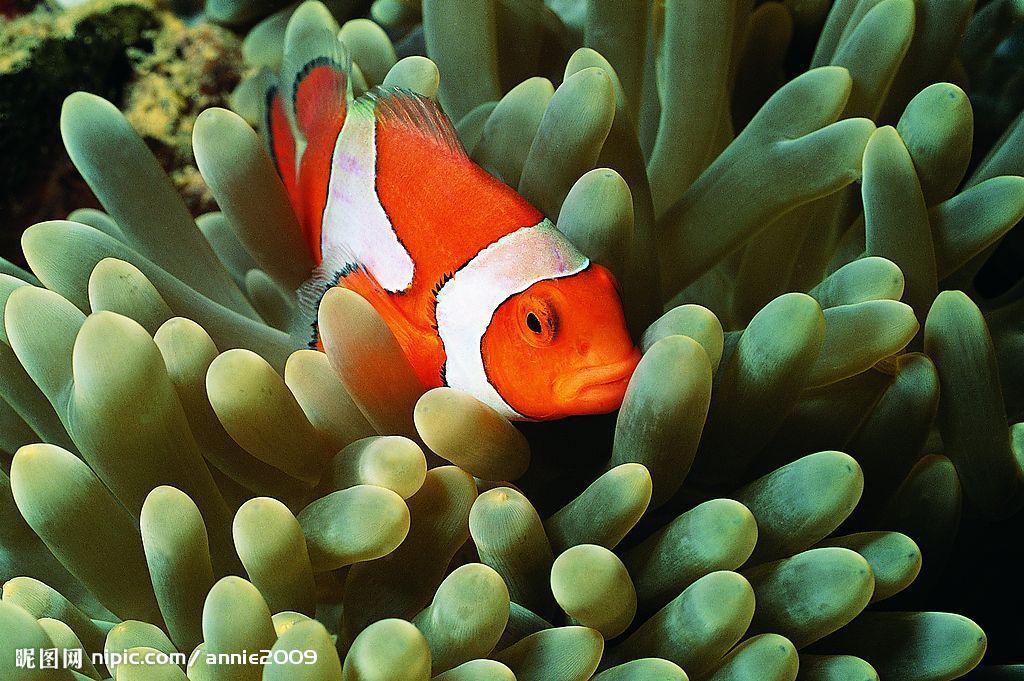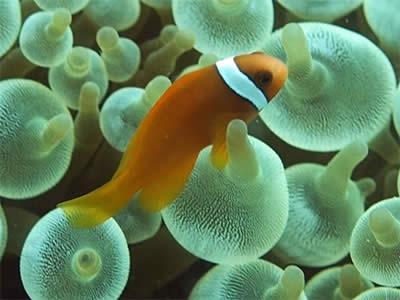The first image is the image on the left, the second image is the image on the right. Considering the images on both sides, is "The right image shows more than one clown fish swimming among tube shapes." valid? Answer yes or no. No. The first image is the image on the left, the second image is the image on the right. Analyze the images presented: Is the assertion "There is exactly one fish in the image on the right." valid? Answer yes or no. Yes. 